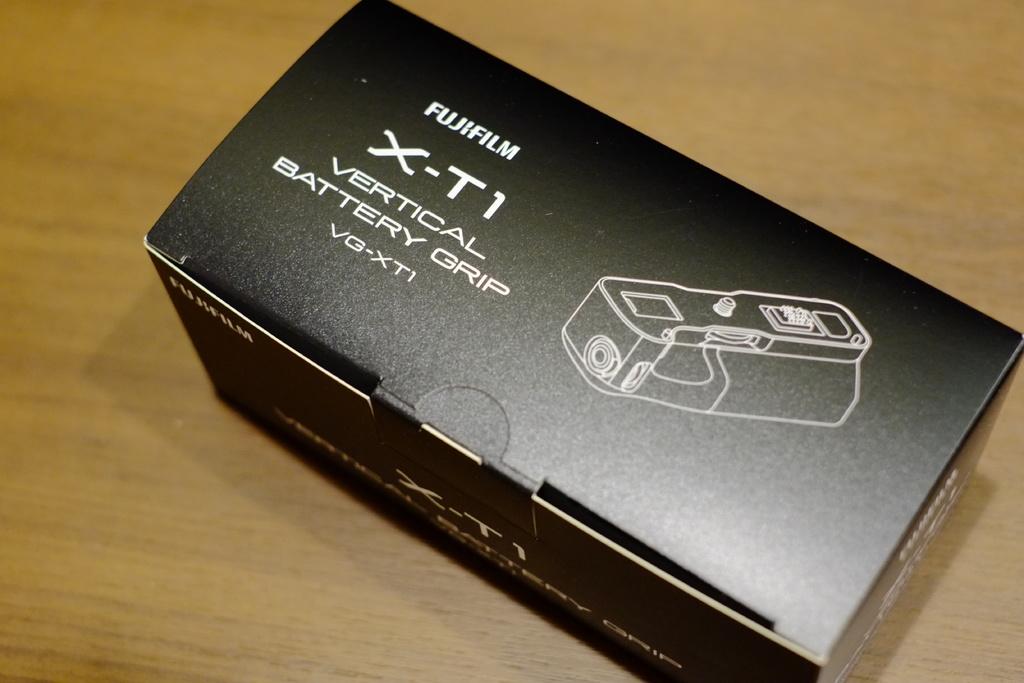What is inside the box?
Offer a terse response. Vertical battery grip. What is the brand of battery?
Provide a short and direct response. Fujifilm. 